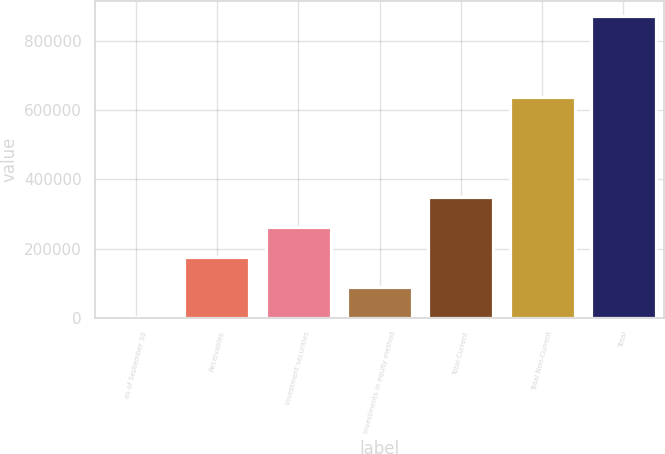Convert chart to OTSL. <chart><loc_0><loc_0><loc_500><loc_500><bar_chart><fcel>as of September 30<fcel>Receivables<fcel>Investment securities<fcel>Investments in equity method<fcel>Total Current<fcel>Total Non-Current<fcel>Total<nl><fcel>2010<fcel>175928<fcel>262887<fcel>88969.1<fcel>349846<fcel>637393<fcel>871601<nl></chart> 